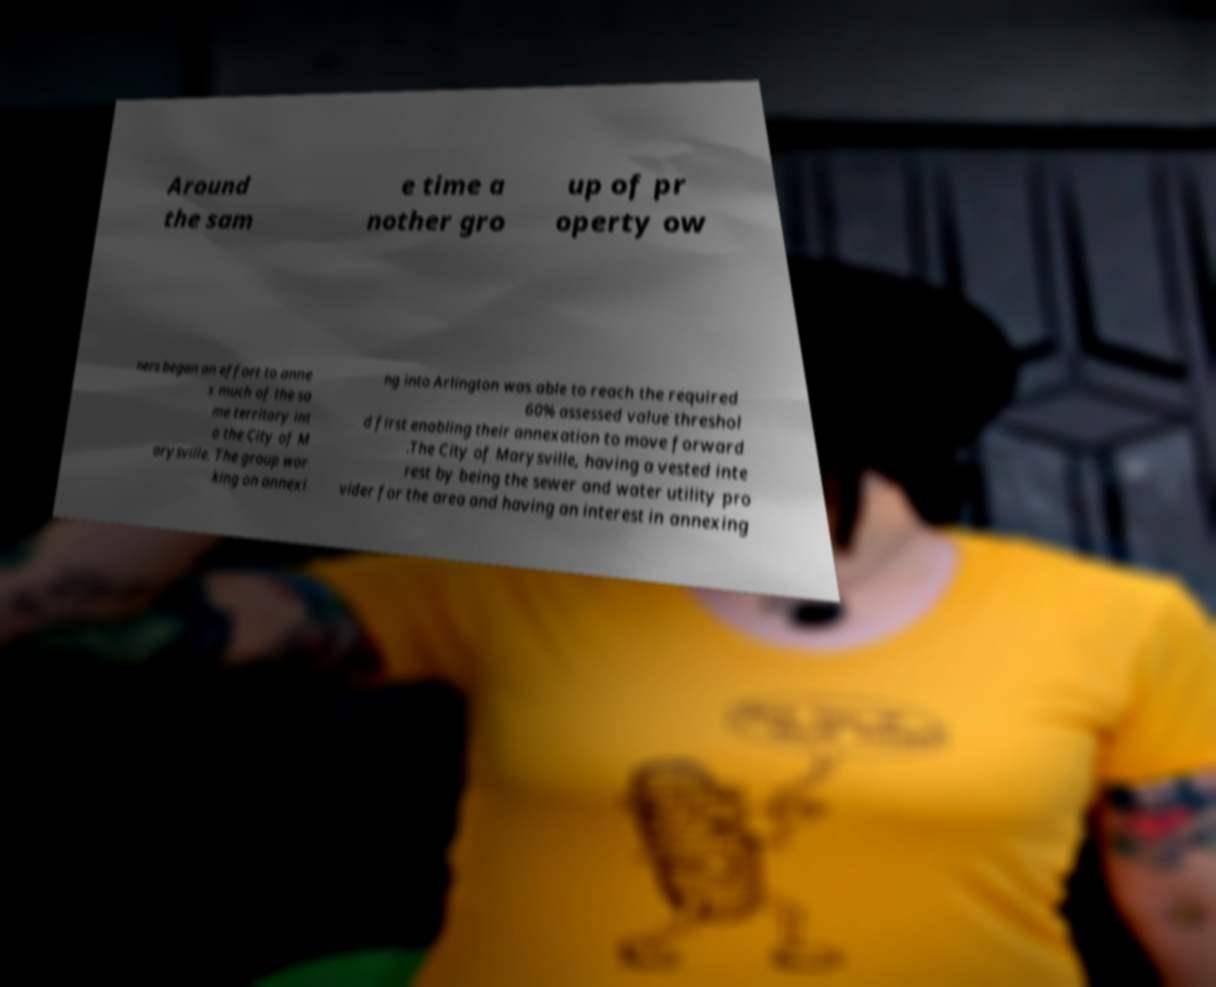Can you accurately transcribe the text from the provided image for me? Around the sam e time a nother gro up of pr operty ow ners began an effort to anne x much of the sa me territory int o the City of M arysville. The group wor king on annexi ng into Arlington was able to reach the required 60% assessed value threshol d first enabling their annexation to move forward .The City of Marysville, having a vested inte rest by being the sewer and water utility pro vider for the area and having an interest in annexing 